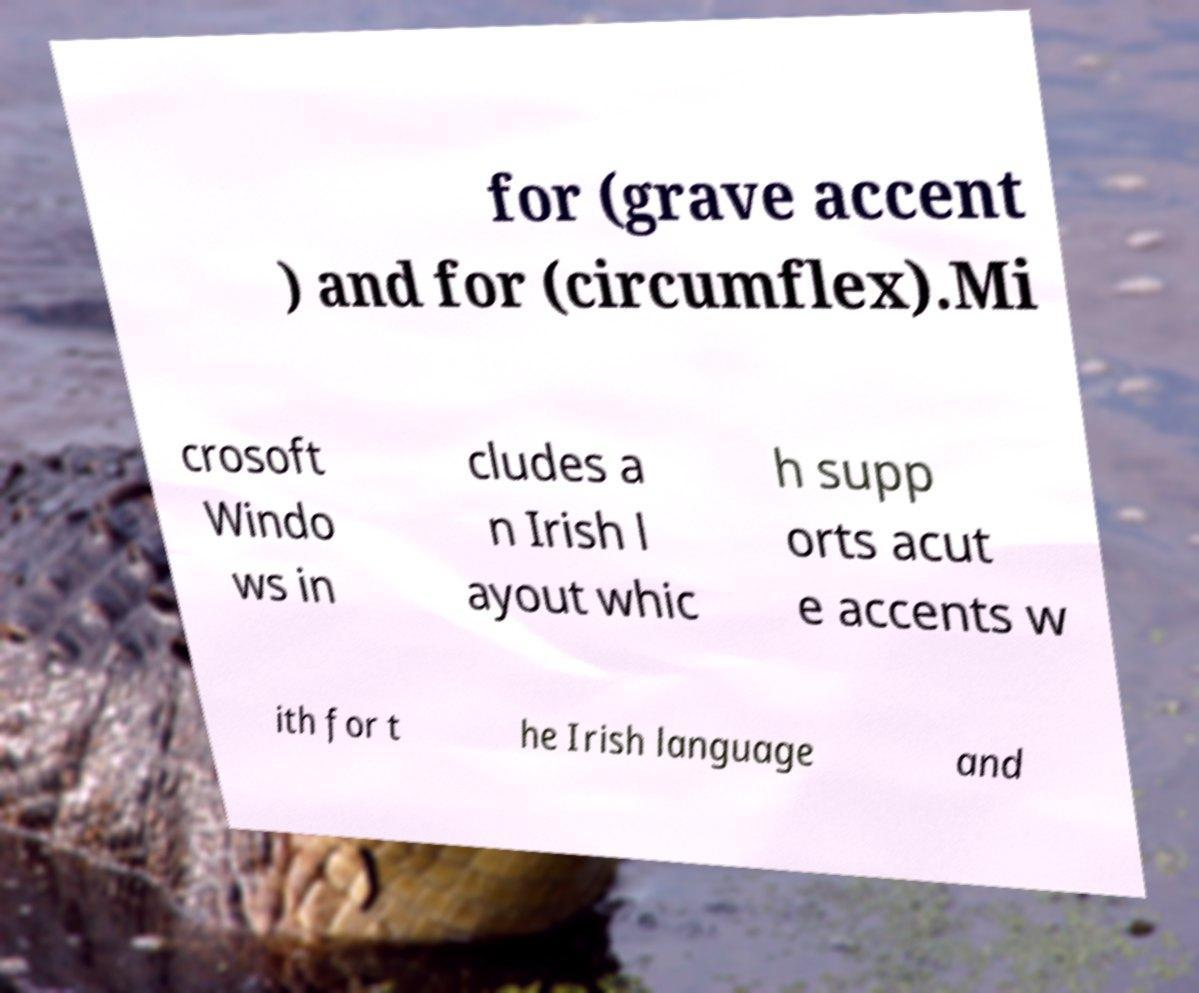There's text embedded in this image that I need extracted. Can you transcribe it verbatim? for (grave accent ) and for (circumflex).Mi crosoft Windo ws in cludes a n Irish l ayout whic h supp orts acut e accents w ith for t he Irish language and 